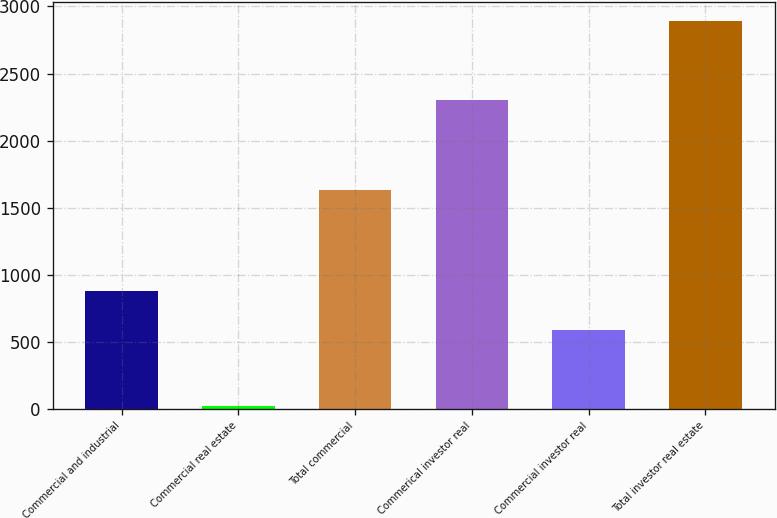<chart> <loc_0><loc_0><loc_500><loc_500><bar_chart><fcel>Commercial and industrial<fcel>Commercial real estate<fcel>Total commercial<fcel>Commerical investor real<fcel>Commercial investor real<fcel>Total investor real estate<nl><fcel>875.7<fcel>23<fcel>1628<fcel>2301<fcel>589<fcel>2890<nl></chart> 